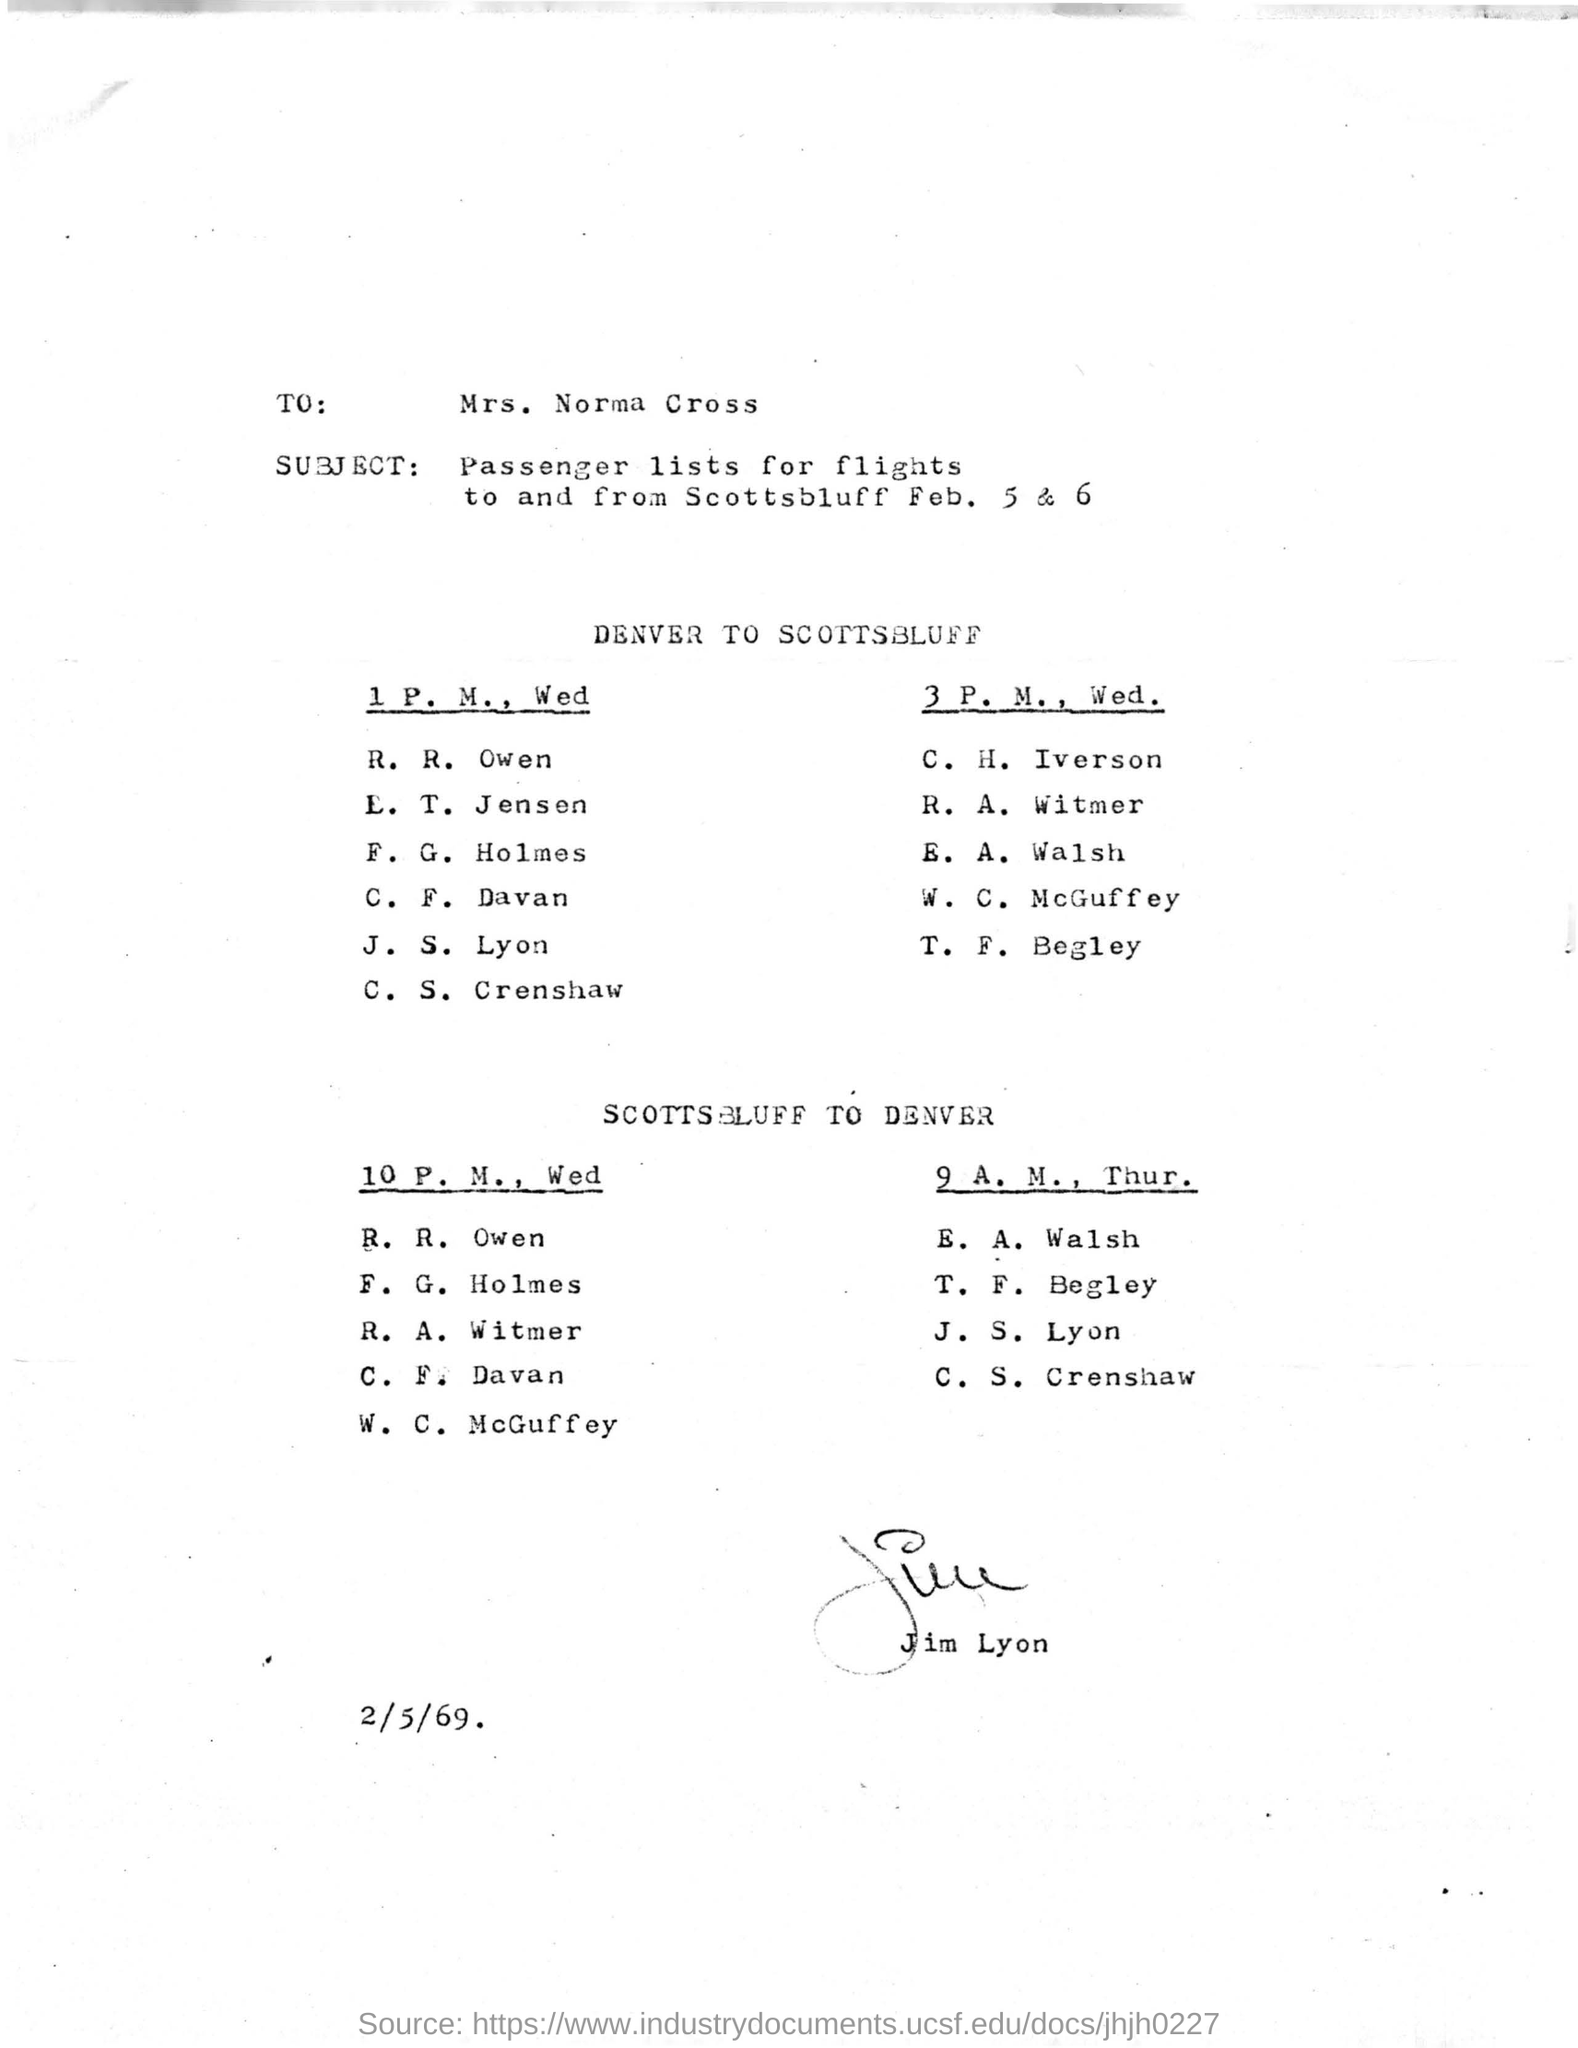Give some essential details in this illustration. The document in question contains a date of February 5th, 1969. The document pertains to passenger lists for flights to and from Scottsbluff on February 5 and 6. The document is addressed to Mrs. Norma Cross. 